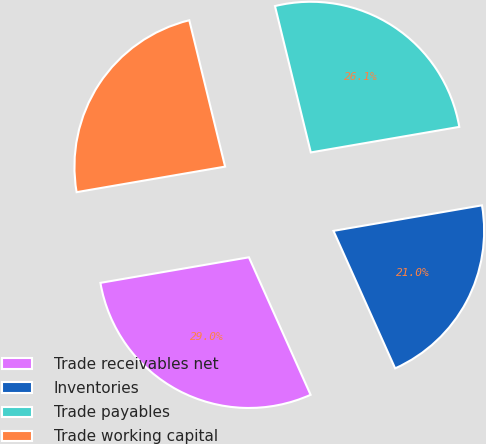Convert chart to OTSL. <chart><loc_0><loc_0><loc_500><loc_500><pie_chart><fcel>Trade receivables net<fcel>Inventories<fcel>Trade payables<fcel>Trade working capital<nl><fcel>29.0%<fcel>21.0%<fcel>26.11%<fcel>23.89%<nl></chart> 